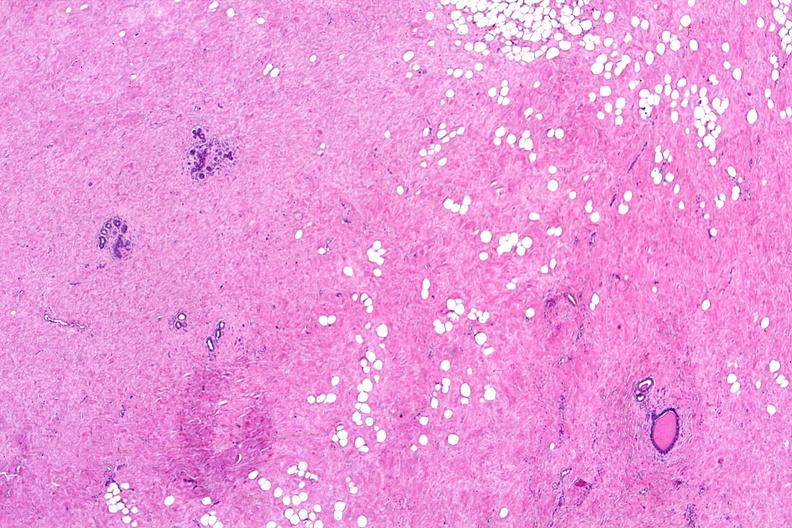s female reproductive present?
Answer the question using a single word or phrase. Yes 